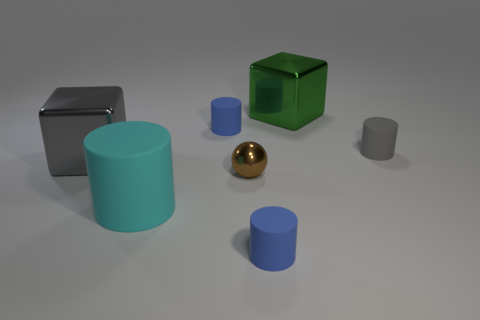Subtract 1 cylinders. How many cylinders are left? 3 Add 5 small matte cylinders. How many small matte cylinders are left? 8 Add 4 gray cylinders. How many gray cylinders exist? 5 Add 1 gray metallic spheres. How many objects exist? 8 Subtract all gray cubes. How many cubes are left? 1 Subtract all big matte cylinders. How many cylinders are left? 3 Subtract 1 cyan cylinders. How many objects are left? 6 Subtract all cylinders. How many objects are left? 3 Subtract all brown cubes. Subtract all blue cylinders. How many cubes are left? 2 Subtract all cyan cylinders. How many green blocks are left? 1 